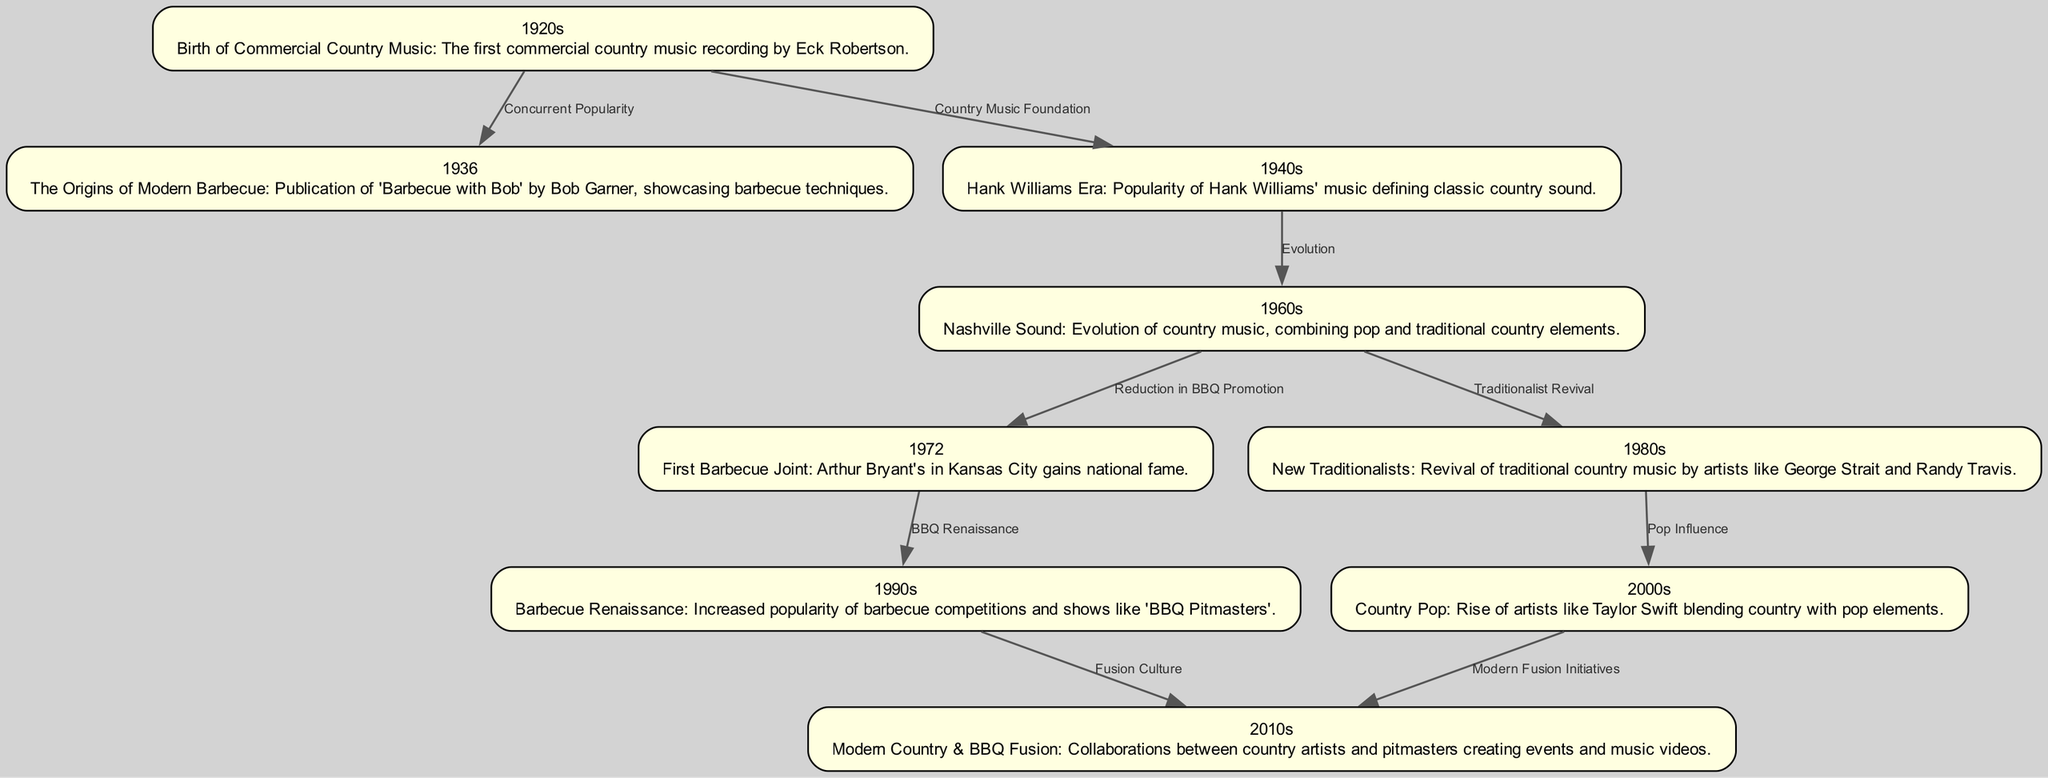What significant event marked the 1920s in country music history? The 1920s saw the birth of commercial country music, with Eck Robertson making the first commercial recording.
Answer: Birth of Commercial Country Music Which publication highlighted barbecue techniques in 1936? In 1936, 'Barbecue with Bob' by Bob Garner was published, showcasing barbecue techniques.
Answer: 'Barbecue with Bob' What decade is known for the Nashville Sound evolution? The 1960s is recognized for the evolution of country music that included the Nashville Sound, blending pop and traditional elements.
Answer: 1960s How many edges are there connecting the nodes in the diagram? The diagram shows 9 edges connecting the various nodes that represent significant events and overlaps in country music and barbecue history.
Answer: 9 What event in the 1970s coincided with the rise of barbecue joints? The first famous barbecue joint, Arthur Bryant's, gained national fame in 1972, coinciding with the growing interest in barbecue cuisine.
Answer: Arthur Bryant's Which two decades are highlighted for their influence on modern country music and barbecue fusion? The 2010s specifically focus on modern country and barbecue fusion, reflecting collaborations between artists and pitmasters, building off the influences of the 2000s.
Answer: 2010s & 2000s How did the 1990s impact barbecue culture? The 1990s experienced a barbecue renaissance characterized by a rise in barbecue competitions and media mentions, such as the show 'BBQ Pitmasters'.
Answer: Barbecue Renaissance What relationship is shown between the 1960s and the 1980s regarding musical trends? The 1960s, highlighting the Nashville Sound, led to a traditionalist revival in the 1980s, marking a shift back to more traditional country music styles.
Answer: Traditionalist Revival Which decade experienced a revival of traditional country music artists? The 1980s is noted for the new traditionalists, with artists like George Strait and Randy Travis leading the revival of traditional country sound.
Answer: 1980s 